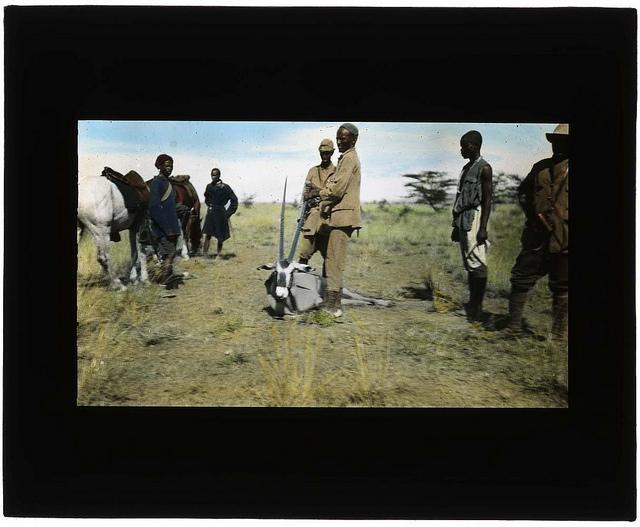Are the men hunting?
Be succinct. Yes. Does the animal have impressive horns?
Quick response, please. Yes. What other animal is pictured?
Give a very brief answer. Horse. 